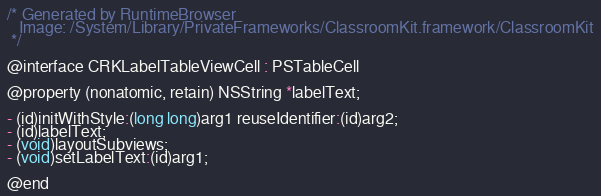<code> <loc_0><loc_0><loc_500><loc_500><_C_>/* Generated by RuntimeBrowser
   Image: /System/Library/PrivateFrameworks/ClassroomKit.framework/ClassroomKit
 */

@interface CRKLabelTableViewCell : PSTableCell

@property (nonatomic, retain) NSString *labelText;

- (id)initWithStyle:(long long)arg1 reuseIdentifier:(id)arg2;
- (id)labelText;
- (void)layoutSubviews;
- (void)setLabelText:(id)arg1;

@end
</code> 